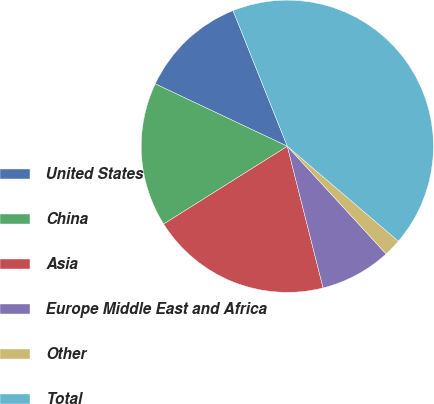Convert chart. <chart><loc_0><loc_0><loc_500><loc_500><pie_chart><fcel>United States<fcel>China<fcel>Asia<fcel>Europe Middle East and Africa<fcel>Other<fcel>Total<nl><fcel>11.92%<fcel>15.96%<fcel>20.0%<fcel>7.88%<fcel>1.93%<fcel>42.31%<nl></chart> 